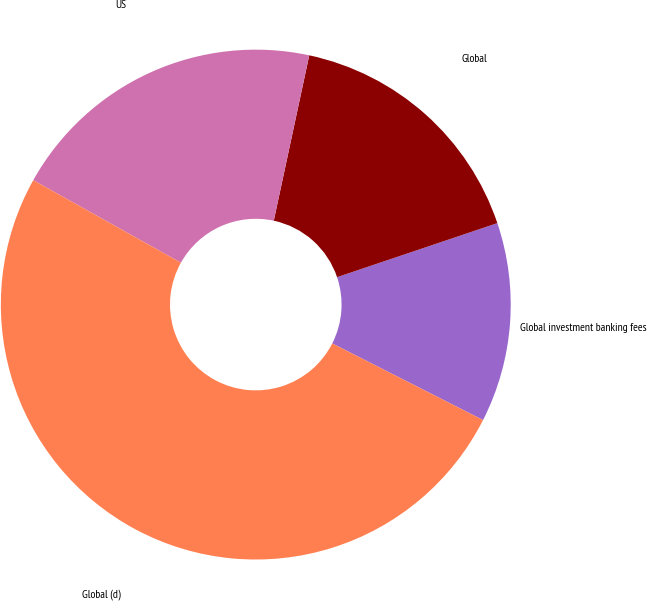<chart> <loc_0><loc_0><loc_500><loc_500><pie_chart><fcel>Global investment banking fees<fcel>Global<fcel>US<fcel>Global (d)<nl><fcel>12.66%<fcel>16.46%<fcel>20.25%<fcel>50.63%<nl></chart> 